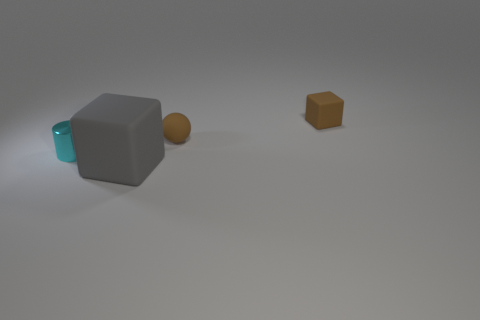Add 4 small blue things. How many objects exist? 8 Subtract all cylinders. How many objects are left? 3 Add 1 small green cubes. How many small green cubes exist? 1 Subtract 0 green spheres. How many objects are left? 4 Subtract all brown balls. Subtract all tiny cyan things. How many objects are left? 2 Add 3 tiny rubber blocks. How many tiny rubber blocks are left? 4 